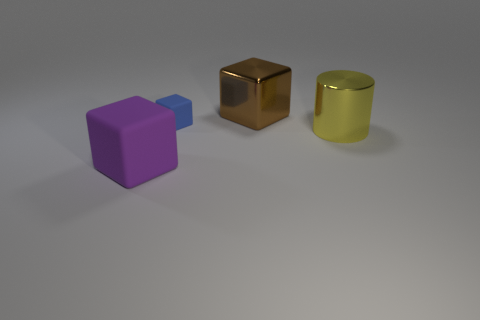What sort of material do these objects look like they're made of? The objects appear to have a smooth, reflective surface quality, suggesting they are made of metal. The cube in the center has a more reflective quality, akin to polished bronze or copper, while the cylindrical object seems like anodized aluminum with its yellowish tint and the matte finish of the purple cube could indicate a painted metal or a plastic material. Is there anything specific about the lighting condition in this image? The lighting in the image is soft and diffused, creating gentle shadows and subtle reflections on the objects, which indicates that the light source is not very harsh and is likely to be coming from above and to the right, simulating an overcast daylight setting or a well-lit indoor scenario with ambient lighting. 